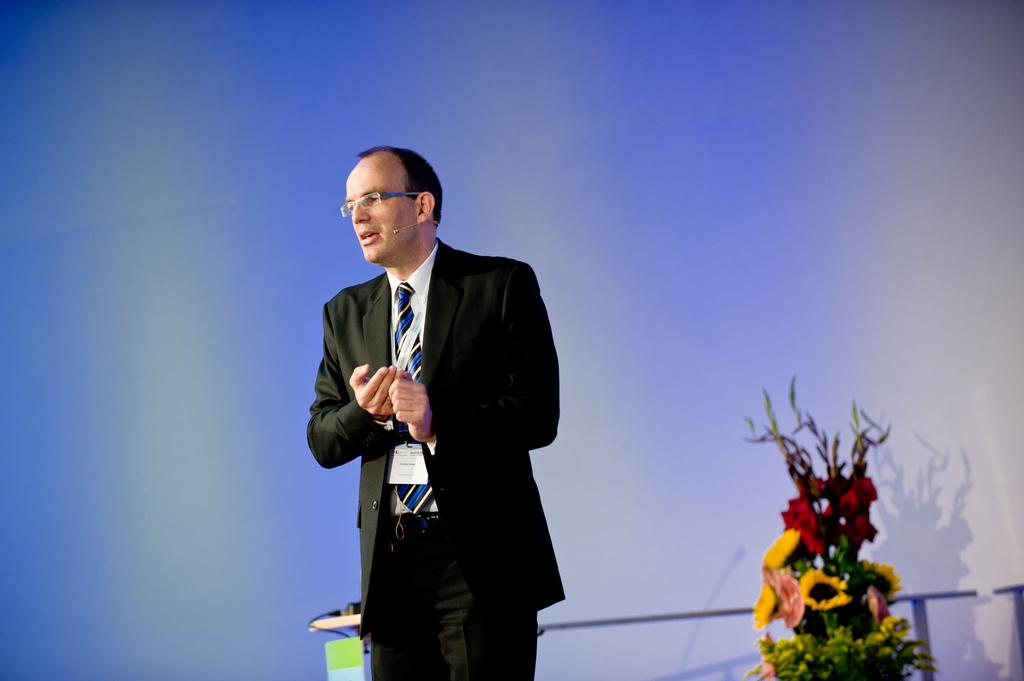What is the main subject of the image? There is a man standing in the image. Can you describe the man's attire? The man is wearing a black coat and a tie. What accessory is the man wearing on his face? The man is wearing glasses (specs). What can be seen in the background of the image? There is a wall in the background of the image. How is the pail being distributed in the image? There is no pail present in the image, so it cannot be distributed. What is the limit of the man's glasses in the image? The image does not provide information about the limit of the man's glasses; it only shows that he is wearing them. 